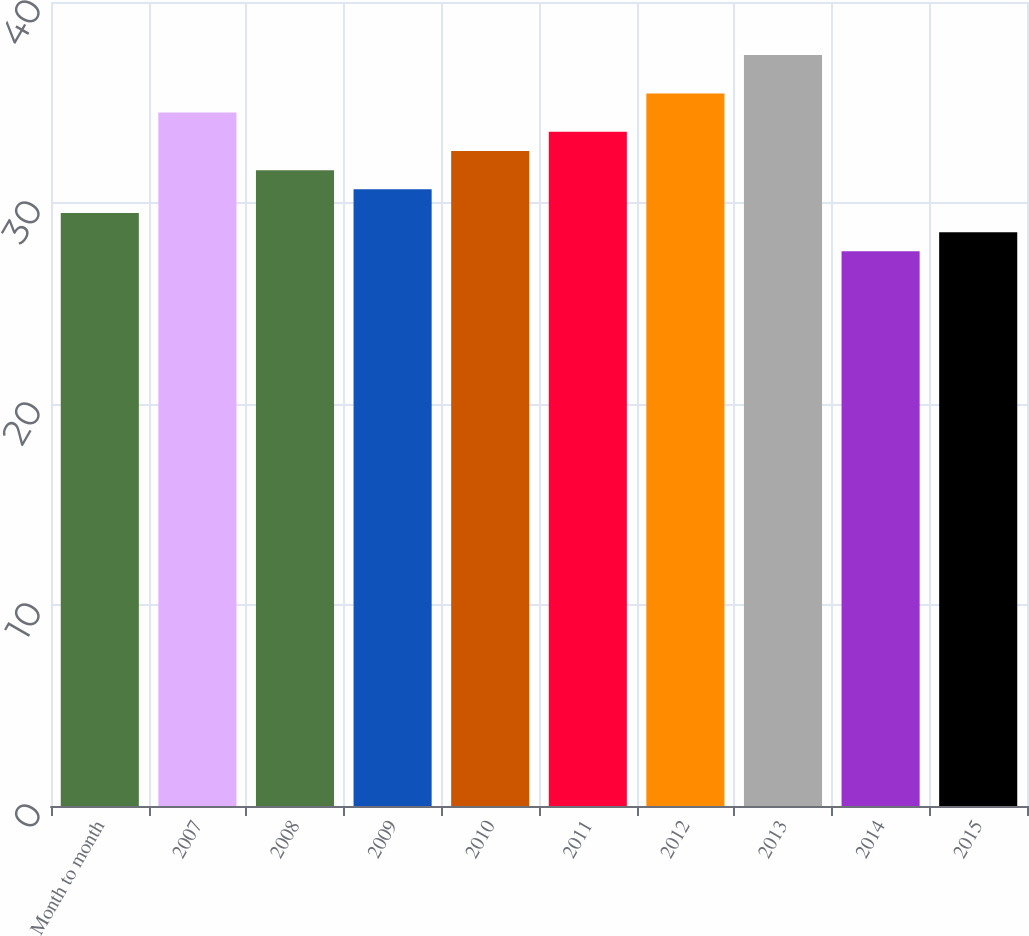<chart> <loc_0><loc_0><loc_500><loc_500><bar_chart><fcel>Month to month<fcel>2007<fcel>2008<fcel>2009<fcel>2010<fcel>2011<fcel>2012<fcel>2013<fcel>2014<fcel>2015<nl><fcel>29.5<fcel>34.5<fcel>31.63<fcel>30.68<fcel>32.59<fcel>33.55<fcel>35.45<fcel>37.36<fcel>27.6<fcel>28.55<nl></chart> 